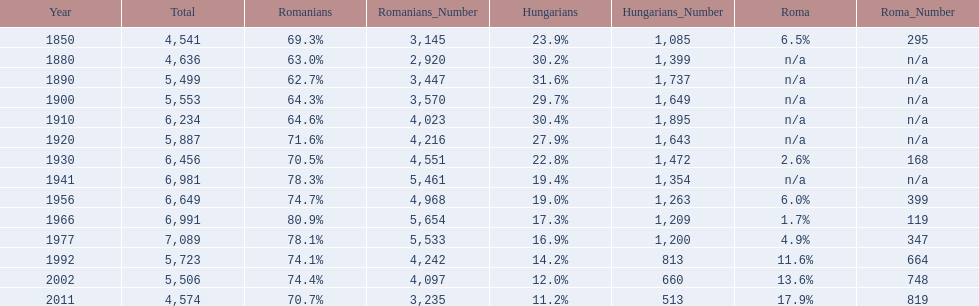Which year had a total of 6,981 and 19.4% hungarians? 1941. 